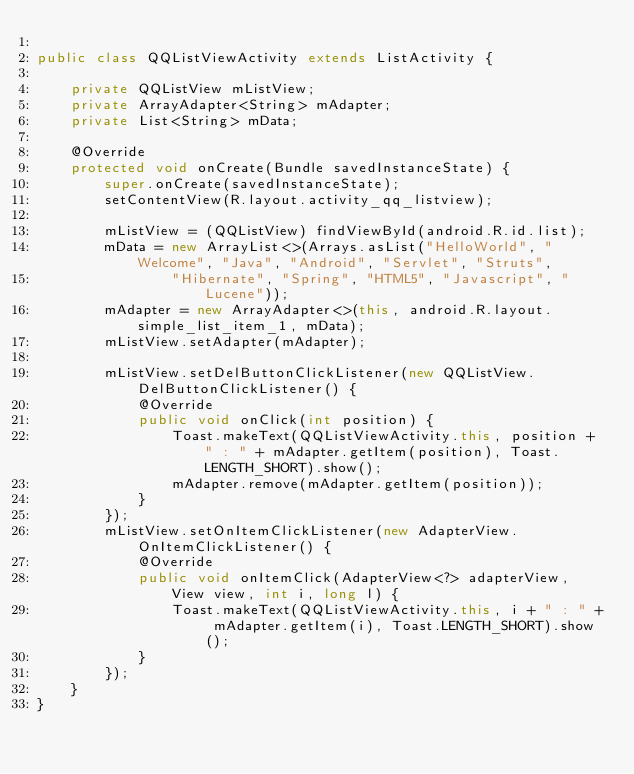<code> <loc_0><loc_0><loc_500><loc_500><_Java_>
public class QQListViewActivity extends ListActivity {

    private QQListView mListView;
    private ArrayAdapter<String> mAdapter;
    private List<String> mData;

    @Override
    protected void onCreate(Bundle savedInstanceState) {
        super.onCreate(savedInstanceState);
        setContentView(R.layout.activity_qq_listview);

        mListView = (QQListView) findViewById(android.R.id.list);
        mData = new ArrayList<>(Arrays.asList("HelloWorld", "Welcome", "Java", "Android", "Servlet", "Struts",
                "Hibernate", "Spring", "HTML5", "Javascript", "Lucene"));
        mAdapter = new ArrayAdapter<>(this, android.R.layout.simple_list_item_1, mData);
        mListView.setAdapter(mAdapter);

        mListView.setDelButtonClickListener(new QQListView.DelButtonClickListener() {
            @Override
            public void onClick(int position) {
                Toast.makeText(QQListViewActivity.this, position + " : " + mAdapter.getItem(position), Toast.LENGTH_SHORT).show();
                mAdapter.remove(mAdapter.getItem(position));
            }
        });
        mListView.setOnItemClickListener(new AdapterView.OnItemClickListener() {
            @Override
            public void onItemClick(AdapterView<?> adapterView, View view, int i, long l) {
                Toast.makeText(QQListViewActivity.this, i + " : " + mAdapter.getItem(i), Toast.LENGTH_SHORT).show();
            }
        });
    }
}
</code> 